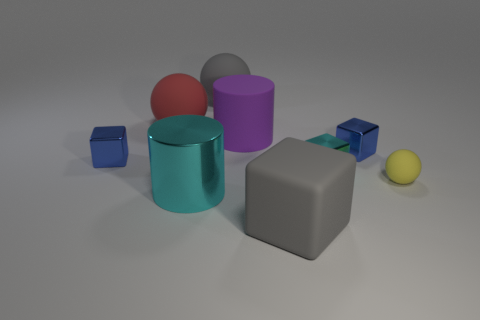There is a block that is to the right of the red rubber thing and left of the small cyan metal thing; what color is it?
Provide a succinct answer. Gray. There is a tiny blue object left of the big purple rubber cylinder; what shape is it?
Ensure brevity in your answer.  Cube. There is a blue cube right of the large gray thing that is on the right side of the large cylinder that is behind the small rubber thing; how big is it?
Your answer should be compact. Small. There is a blue thing that is left of the purple matte object; how many tiny things are on the left side of it?
Your answer should be very brief. 0. There is a matte sphere that is to the left of the large purple rubber thing and on the right side of the big red rubber sphere; what is its size?
Your answer should be very brief. Large. What number of metal things are tiny purple blocks or gray spheres?
Your answer should be very brief. 0. What is the small cyan block made of?
Your response must be concise. Metal. The gray thing that is to the right of the gray object behind the small blue cube that is on the right side of the big purple matte cylinder is made of what material?
Provide a succinct answer. Rubber. There is a cyan shiny object that is the same size as the purple cylinder; what shape is it?
Keep it short and to the point. Cylinder. What number of objects are big cyan shiny balls or cyan metallic objects that are right of the large cyan cylinder?
Your response must be concise. 1. 